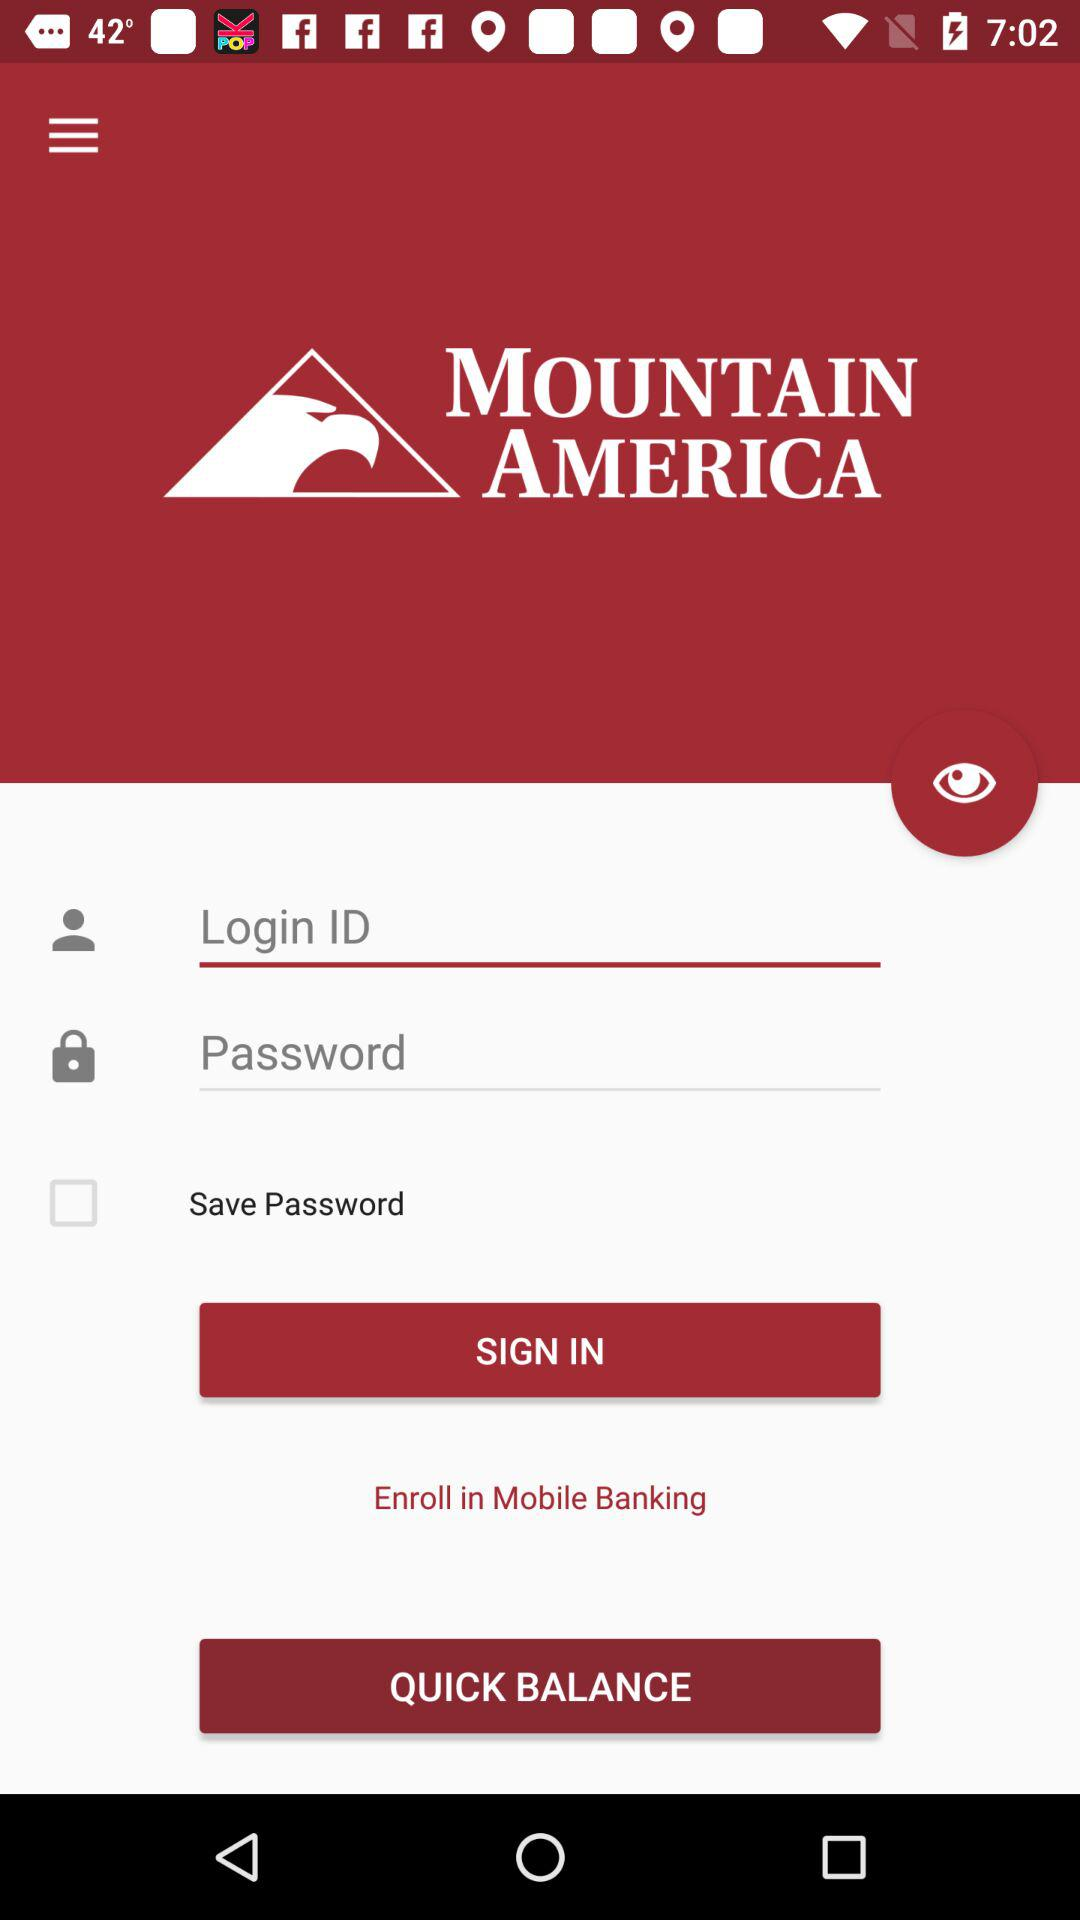What is the name of the application? The name of the application is "MOUNTAIN AMERICA". 